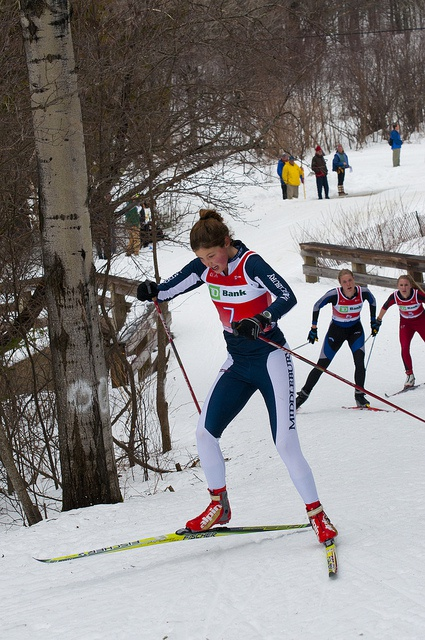Describe the objects in this image and their specific colors. I can see people in black, darkgray, brown, and lightgray tones, people in black, navy, gray, and brown tones, skis in black, darkgray, lightgray, and gray tones, people in black, maroon, brown, and gray tones, and people in black, maroon, and gray tones in this image. 